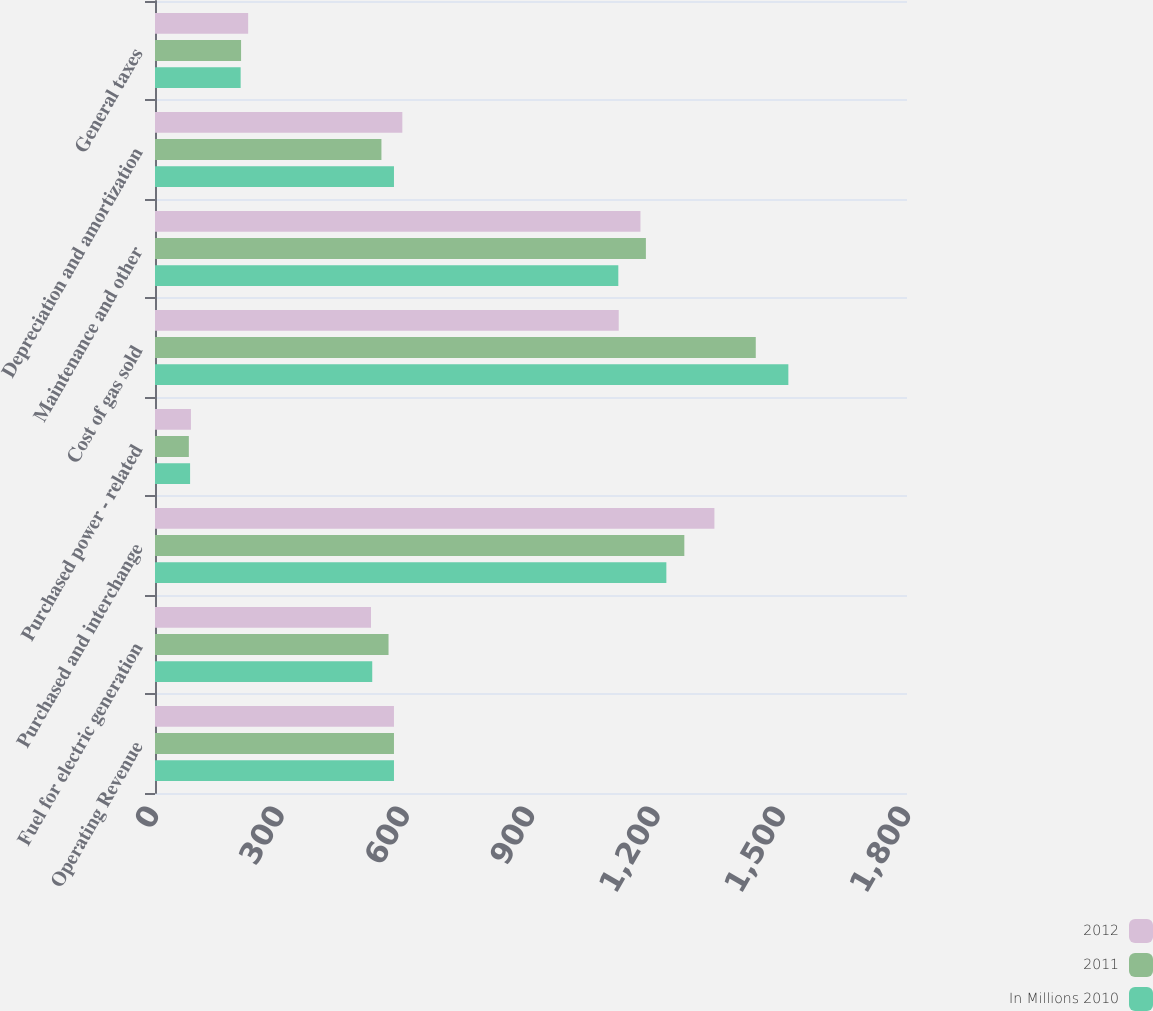Convert chart. <chart><loc_0><loc_0><loc_500><loc_500><stacked_bar_chart><ecel><fcel>Operating Revenue<fcel>Fuel for electric generation<fcel>Purchased and interchange<fcel>Purchased power - related<fcel>Cost of gas sold<fcel>Maintenance and other<fcel>Depreciation and amortization<fcel>General taxes<nl><fcel>2012<fcel>572<fcel>517<fcel>1339<fcel>86<fcel>1110<fcel>1162<fcel>592<fcel>223<nl><fcel>2011<fcel>572<fcel>559<fcel>1267<fcel>81<fcel>1438<fcel>1175<fcel>542<fcel>206<nl><fcel>In Millions 2010<fcel>572<fcel>520<fcel>1224<fcel>84<fcel>1516<fcel>1109<fcel>572<fcel>205<nl></chart> 